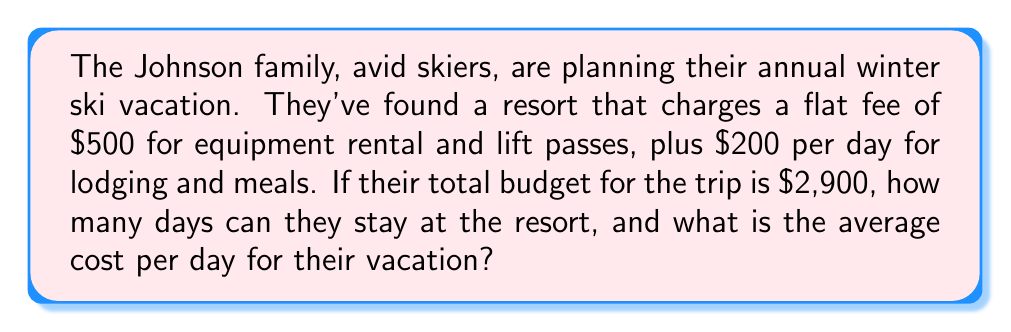Could you help me with this problem? Let's approach this step-by-step using a linear equation:

1) Let $x$ be the number of days for the vacation.

2) The total cost of the vacation can be expressed as:
   $500 + 200x = 2900$

3) Solve for $x$:
   $200x = 2900 - 500$
   $200x = 2400$
   $x = 2400 / 200 = 12$ days

4) To find the average cost per day, divide the total cost by the number of days:
   Average cost per day = $2900 / 12 = $241.67$ per day

5) We can verify this using the linear equation:
   $y = mx + b$, where:
   $y$ is the total cost
   $m$ is the daily rate
   $x$ is the number of days
   $b$ is the flat fee

   $2900 = 200(12) + 500$
   $2900 = 2400 + 500$
   $2900 = 2900$

This confirms our calculation is correct.
Answer: The Johnson family can stay at the resort for 12 days, and the average cost per day for their vacation is $241.67. 